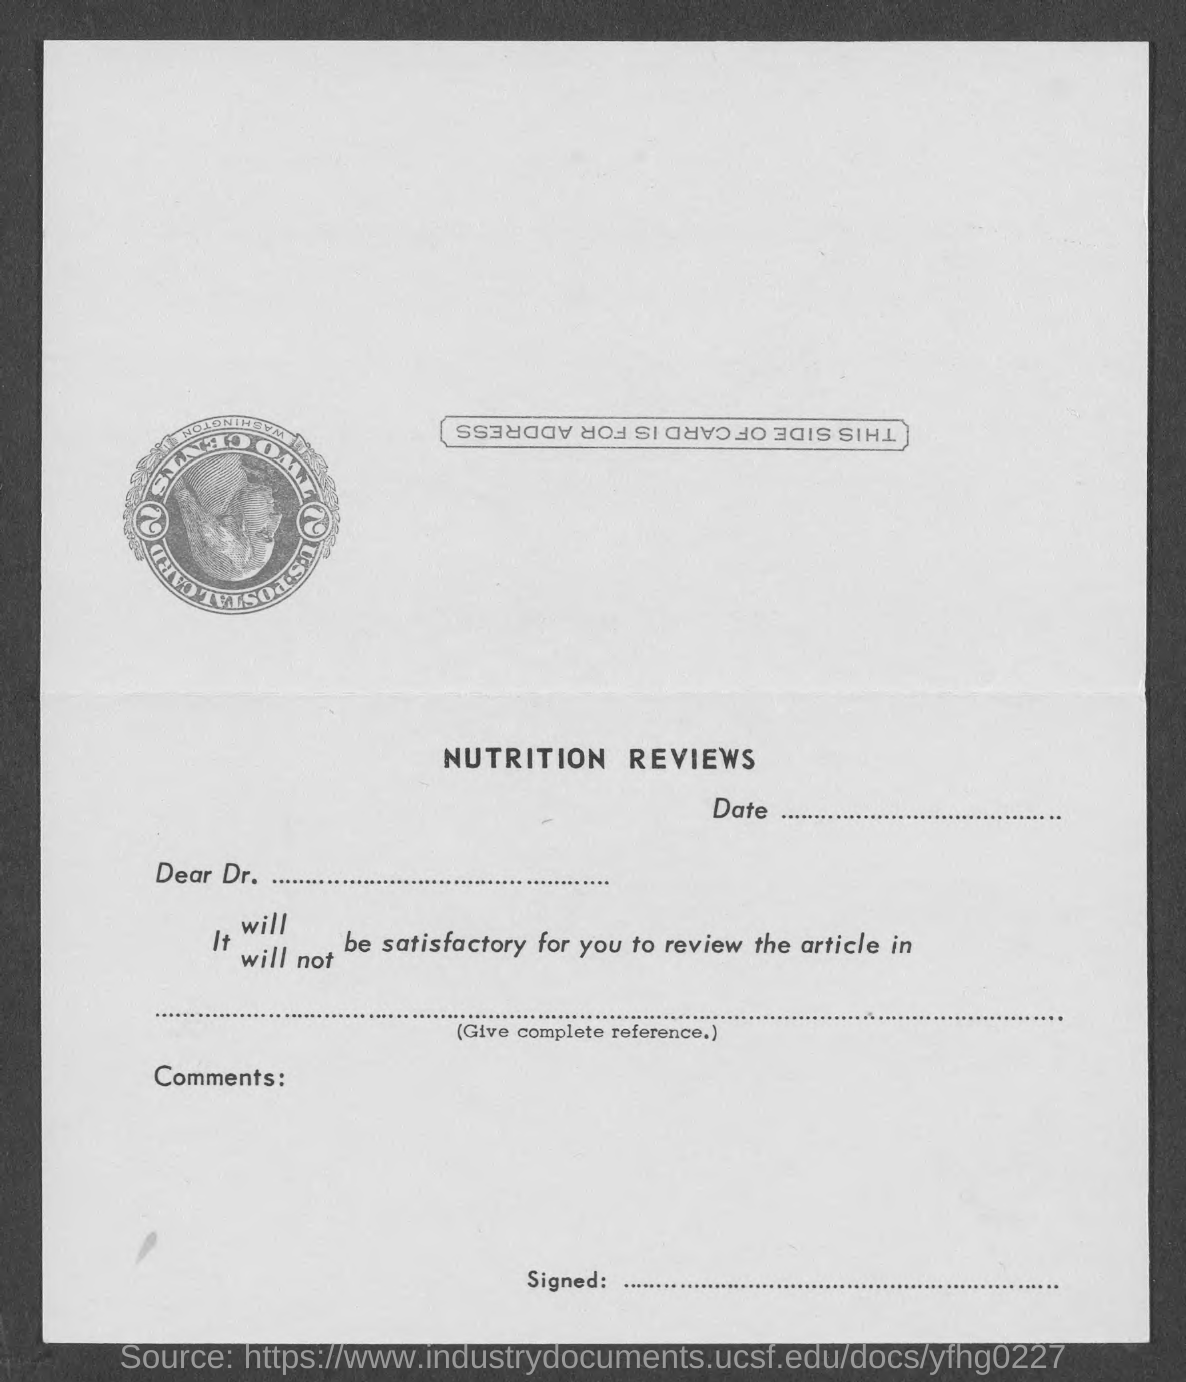Draw attention to some important aspects in this diagram. This form is on NUTRITION REVIEWS. 